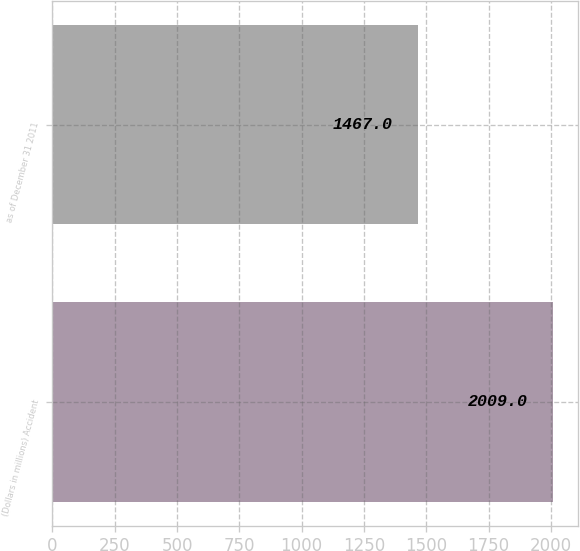Convert chart to OTSL. <chart><loc_0><loc_0><loc_500><loc_500><bar_chart><fcel>(Dollars in millions) Accident<fcel>as of December 31 2011<nl><fcel>2009<fcel>1467<nl></chart> 